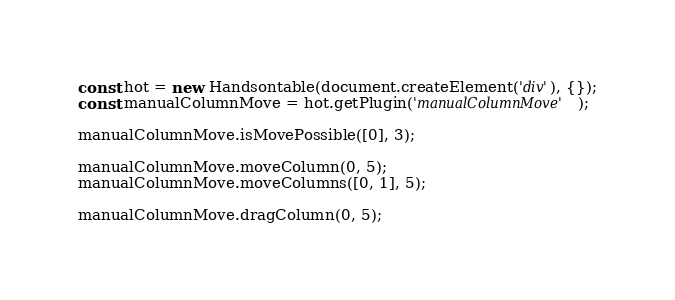<code> <loc_0><loc_0><loc_500><loc_500><_TypeScript_>const hot = new Handsontable(document.createElement('div'), {});
const manualColumnMove = hot.getPlugin('manualColumnMove');

manualColumnMove.isMovePossible([0], 3);

manualColumnMove.moveColumn(0, 5);
manualColumnMove.moveColumns([0, 1], 5);

manualColumnMove.dragColumn(0, 5);</code> 